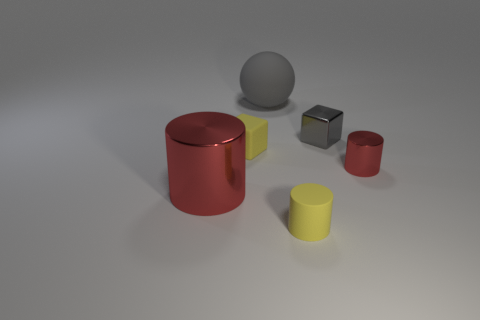Add 3 large brown rubber cylinders. How many objects exist? 9 Subtract all balls. How many objects are left? 5 Add 2 small yellow rubber cylinders. How many small yellow rubber cylinders are left? 3 Add 1 small red metal cylinders. How many small red metal cylinders exist? 2 Subtract 0 cyan spheres. How many objects are left? 6 Subtract all gray things. Subtract all big matte spheres. How many objects are left? 3 